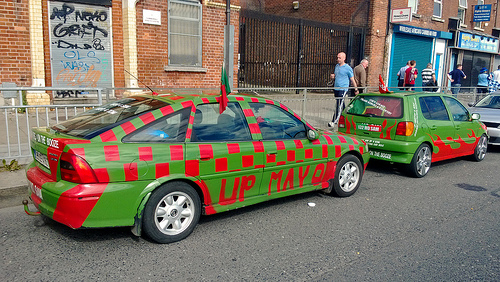<image>
Can you confirm if the road is under the car? Yes. The road is positioned underneath the car, with the car above it in the vertical space. Is the man in the car? No. The man is not contained within the car. These objects have a different spatial relationship. Is the man in front of the up? No. The man is not in front of the up. The spatial positioning shows a different relationship between these objects. 